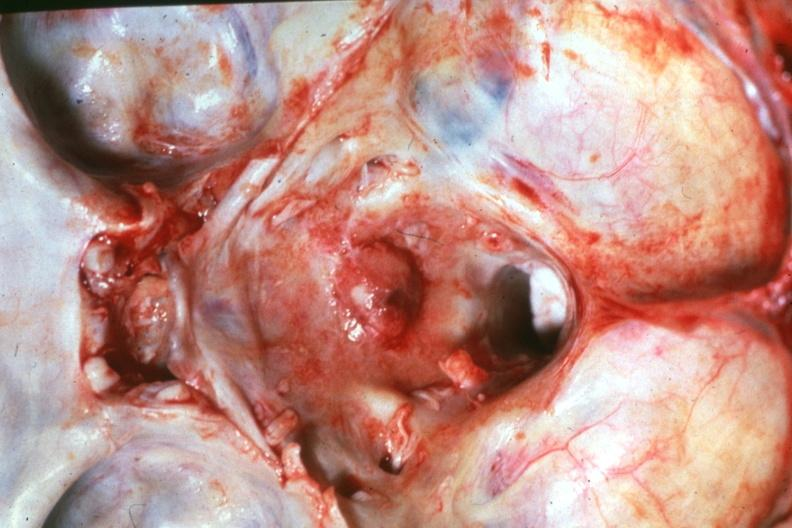what does this image show?
Answer the question using a single word or phrase. Close-up natural color dr garcia tumors b67 